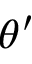Convert formula to latex. <formula><loc_0><loc_0><loc_500><loc_500>\theta ^ { \prime }</formula> 